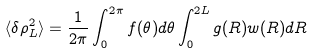Convert formula to latex. <formula><loc_0><loc_0><loc_500><loc_500>\langle \delta \rho _ { L } ^ { 2 } \rangle = \frac { 1 } { 2 \pi } \int _ { 0 } ^ { 2 \pi } f ( \theta ) d \theta \int _ { 0 } ^ { 2 L } g ( R ) w ( R ) d R</formula> 